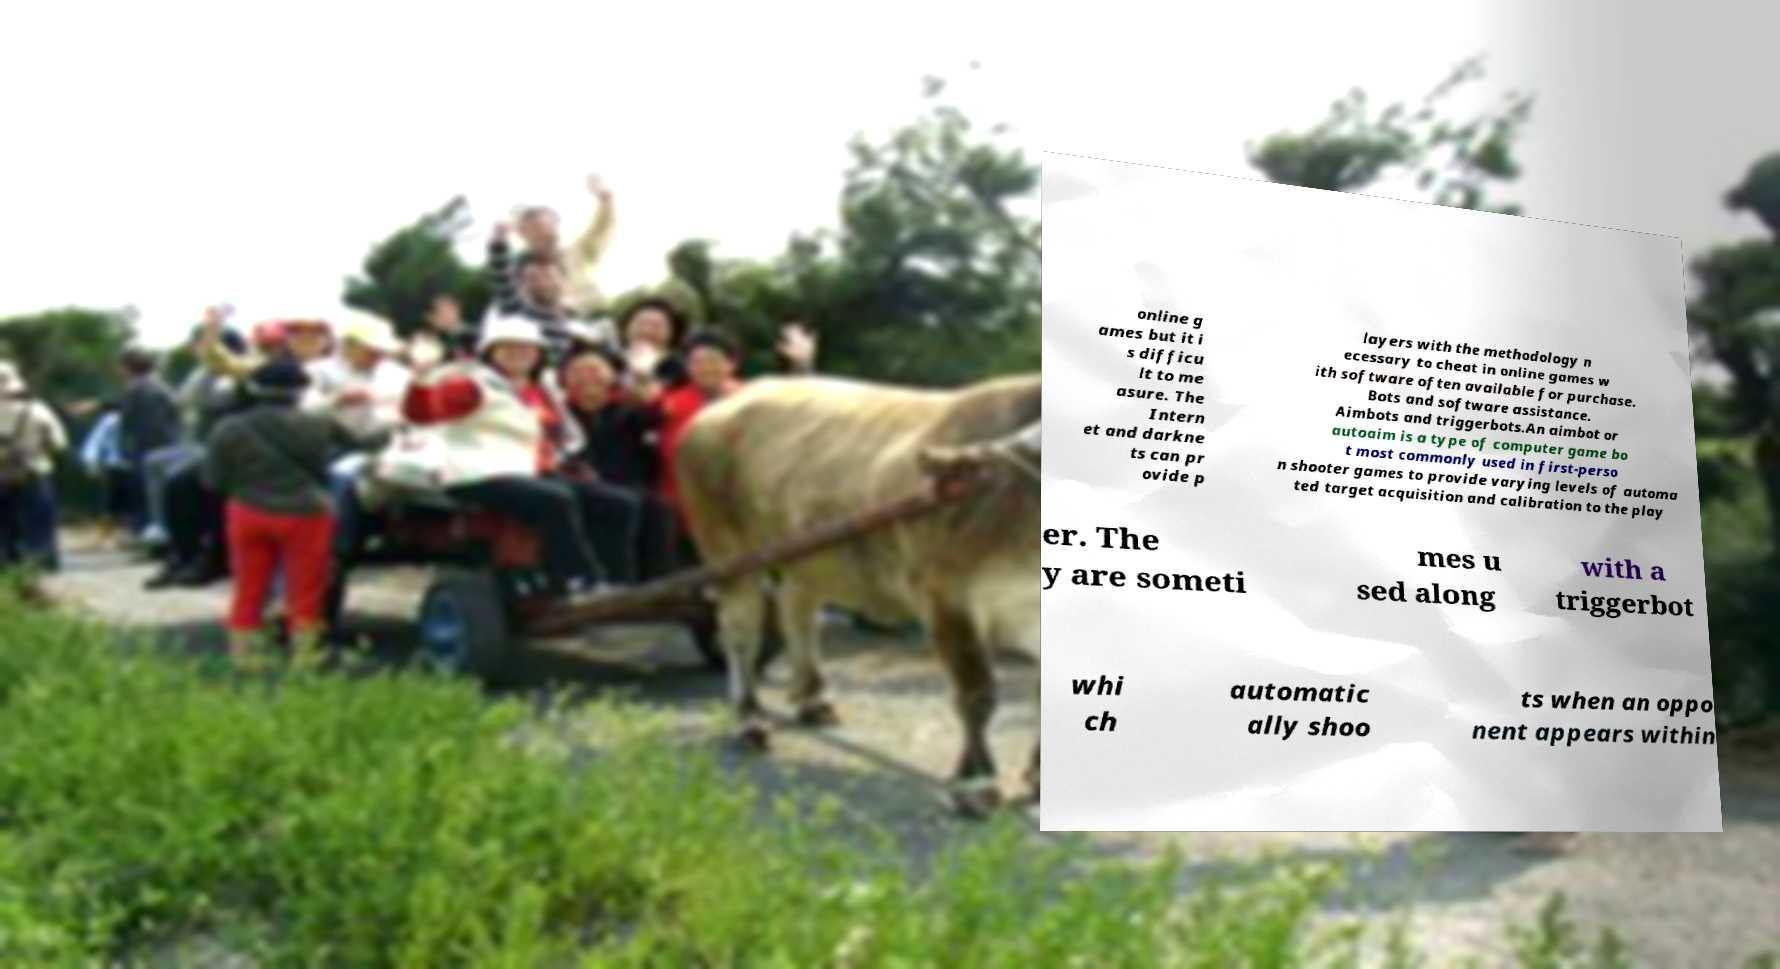Could you assist in decoding the text presented in this image and type it out clearly? online g ames but it i s difficu lt to me asure. The Intern et and darkne ts can pr ovide p layers with the methodology n ecessary to cheat in online games w ith software often available for purchase. Bots and software assistance. Aimbots and triggerbots.An aimbot or autoaim is a type of computer game bo t most commonly used in first-perso n shooter games to provide varying levels of automa ted target acquisition and calibration to the play er. The y are someti mes u sed along with a triggerbot whi ch automatic ally shoo ts when an oppo nent appears within 